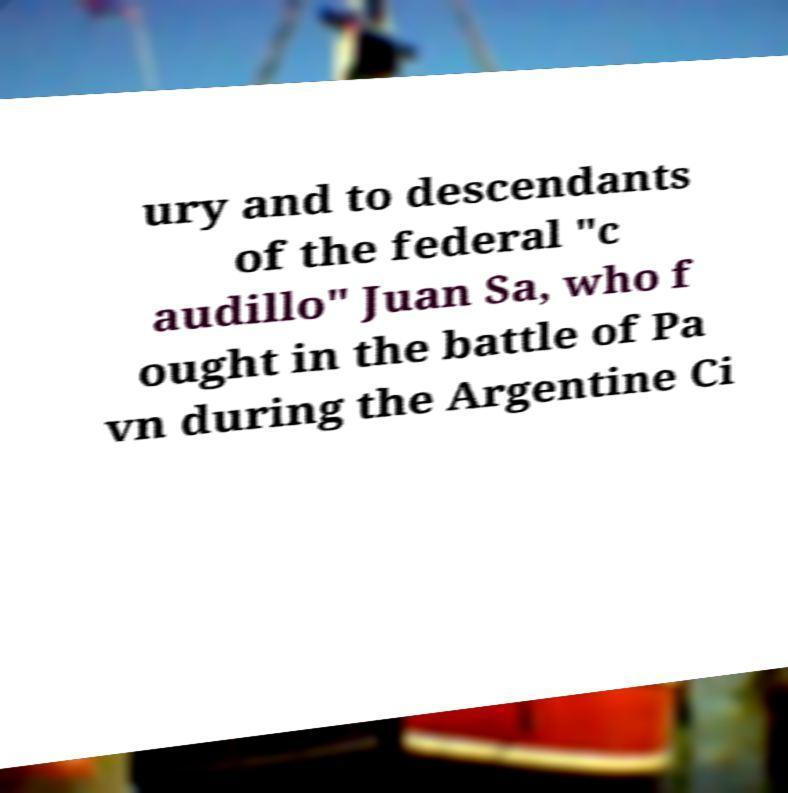There's text embedded in this image that I need extracted. Can you transcribe it verbatim? ury and to descendants of the federal "c audillo" Juan Sa, who f ought in the battle of Pa vn during the Argentine Ci 